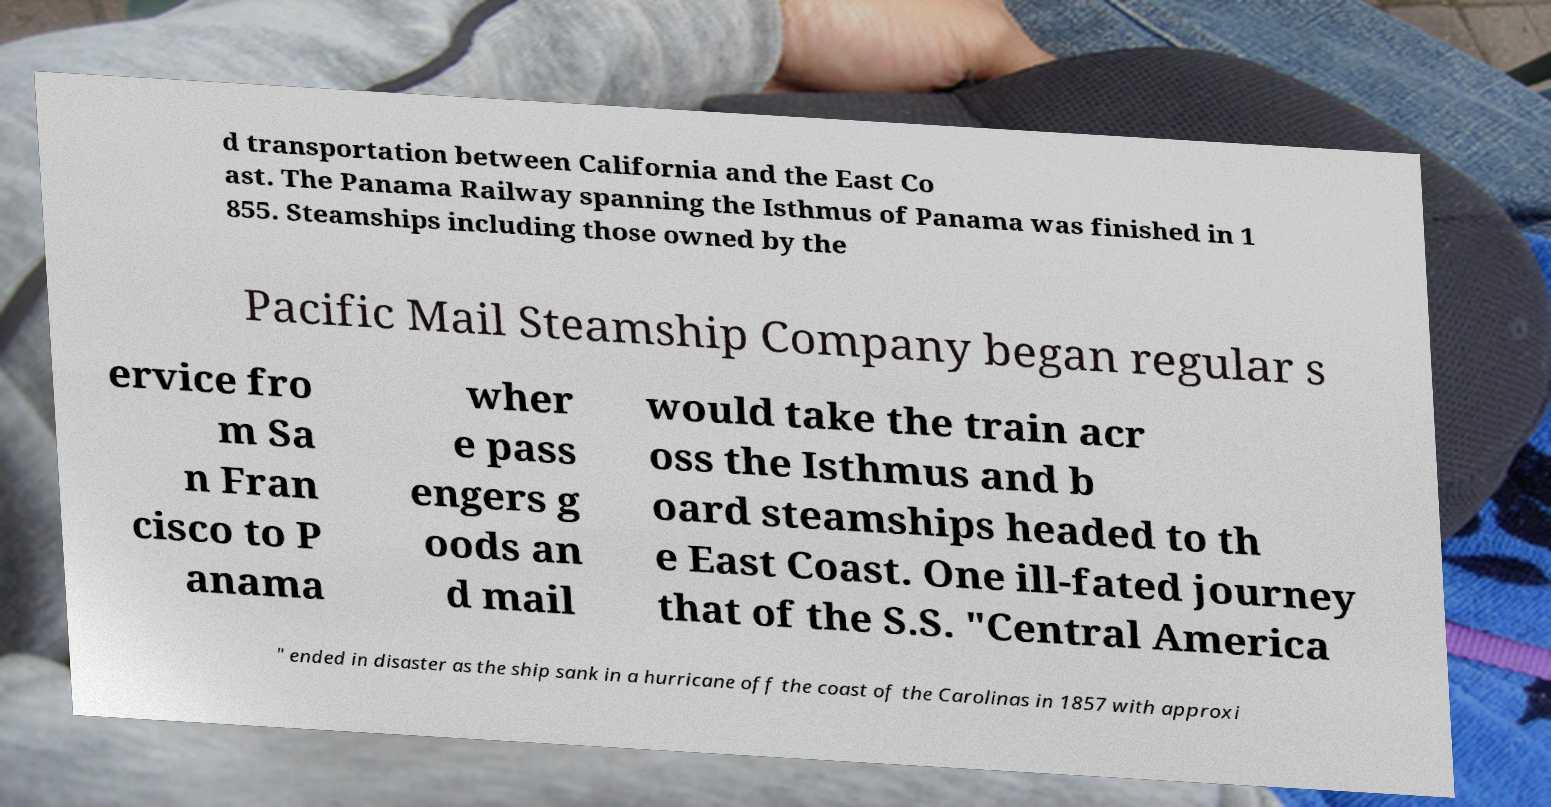For documentation purposes, I need the text within this image transcribed. Could you provide that? d transportation between California and the East Co ast. The Panama Railway spanning the Isthmus of Panama was finished in 1 855. Steamships including those owned by the Pacific Mail Steamship Company began regular s ervice fro m Sa n Fran cisco to P anama wher e pass engers g oods an d mail would take the train acr oss the Isthmus and b oard steamships headed to th e East Coast. One ill-fated journey that of the S.S. "Central America " ended in disaster as the ship sank in a hurricane off the coast of the Carolinas in 1857 with approxi 